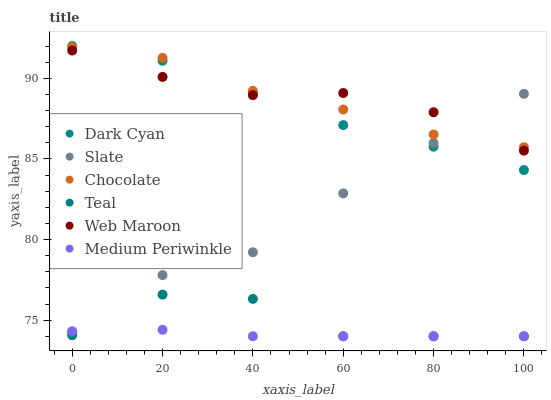Does Medium Periwinkle have the minimum area under the curve?
Answer yes or no. Yes. Does Web Maroon have the maximum area under the curve?
Answer yes or no. Yes. Does Slate have the minimum area under the curve?
Answer yes or no. No. Does Slate have the maximum area under the curve?
Answer yes or no. No. Is Medium Periwinkle the smoothest?
Answer yes or no. Yes. Is Teal the roughest?
Answer yes or no. Yes. Is Slate the smoothest?
Answer yes or no. No. Is Slate the roughest?
Answer yes or no. No. Does Medium Periwinkle have the lowest value?
Answer yes or no. Yes. Does Slate have the lowest value?
Answer yes or no. No. Does Dark Cyan have the highest value?
Answer yes or no. Yes. Does Slate have the highest value?
Answer yes or no. No. Is Medium Periwinkle less than Dark Cyan?
Answer yes or no. Yes. Is Web Maroon greater than Teal?
Answer yes or no. Yes. Does Dark Cyan intersect Chocolate?
Answer yes or no. Yes. Is Dark Cyan less than Chocolate?
Answer yes or no. No. Is Dark Cyan greater than Chocolate?
Answer yes or no. No. Does Medium Periwinkle intersect Dark Cyan?
Answer yes or no. No. 